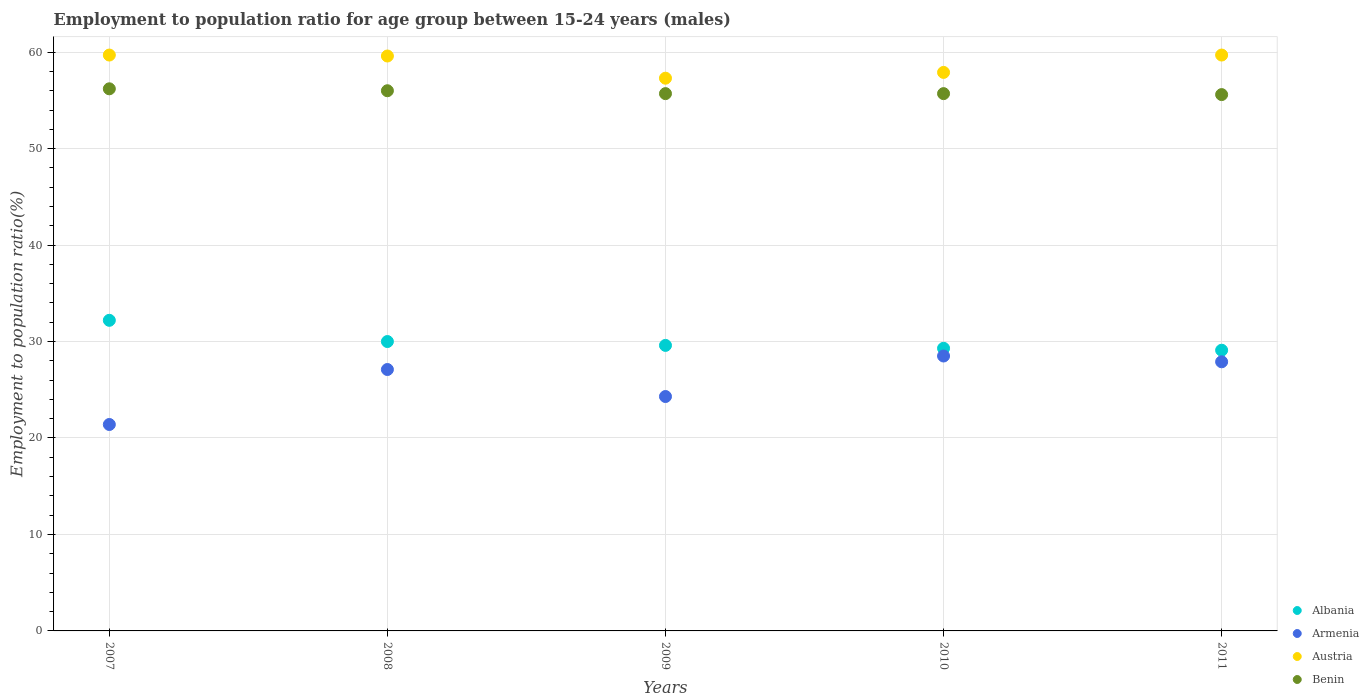How many different coloured dotlines are there?
Offer a very short reply. 4. Is the number of dotlines equal to the number of legend labels?
Keep it short and to the point. Yes. What is the employment to population ratio in Albania in 2009?
Give a very brief answer. 29.6. Across all years, what is the maximum employment to population ratio in Benin?
Your answer should be very brief. 56.2. Across all years, what is the minimum employment to population ratio in Benin?
Offer a very short reply. 55.6. What is the total employment to population ratio in Albania in the graph?
Provide a short and direct response. 150.2. What is the difference between the employment to population ratio in Austria in 2007 and that in 2008?
Offer a terse response. 0.1. What is the difference between the employment to population ratio in Austria in 2009 and the employment to population ratio in Armenia in 2008?
Keep it short and to the point. 30.2. What is the average employment to population ratio in Albania per year?
Keep it short and to the point. 30.04. In the year 2011, what is the difference between the employment to population ratio in Austria and employment to population ratio in Albania?
Your answer should be compact. 30.6. What is the ratio of the employment to population ratio in Benin in 2008 to that in 2009?
Your response must be concise. 1.01. Is the employment to population ratio in Albania in 2007 less than that in 2010?
Make the answer very short. No. What is the difference between the highest and the second highest employment to population ratio in Austria?
Keep it short and to the point. 0. What is the difference between the highest and the lowest employment to population ratio in Armenia?
Offer a very short reply. 7.1. In how many years, is the employment to population ratio in Austria greater than the average employment to population ratio in Austria taken over all years?
Offer a very short reply. 3. Is the sum of the employment to population ratio in Austria in 2007 and 2011 greater than the maximum employment to population ratio in Armenia across all years?
Offer a terse response. Yes. Is it the case that in every year, the sum of the employment to population ratio in Austria and employment to population ratio in Benin  is greater than the employment to population ratio in Albania?
Your answer should be very brief. Yes. Does the employment to population ratio in Austria monotonically increase over the years?
Your answer should be very brief. No. Is the employment to population ratio in Benin strictly greater than the employment to population ratio in Albania over the years?
Provide a short and direct response. Yes. Is the employment to population ratio in Benin strictly less than the employment to population ratio in Austria over the years?
Keep it short and to the point. Yes. What is the difference between two consecutive major ticks on the Y-axis?
Offer a terse response. 10. Does the graph contain grids?
Keep it short and to the point. Yes. How many legend labels are there?
Make the answer very short. 4. How are the legend labels stacked?
Make the answer very short. Vertical. What is the title of the graph?
Your answer should be very brief. Employment to population ratio for age group between 15-24 years (males). What is the label or title of the X-axis?
Your answer should be compact. Years. What is the label or title of the Y-axis?
Your answer should be compact. Employment to population ratio(%). What is the Employment to population ratio(%) in Albania in 2007?
Offer a terse response. 32.2. What is the Employment to population ratio(%) in Armenia in 2007?
Provide a short and direct response. 21.4. What is the Employment to population ratio(%) of Austria in 2007?
Offer a terse response. 59.7. What is the Employment to population ratio(%) of Benin in 2007?
Provide a succinct answer. 56.2. What is the Employment to population ratio(%) in Armenia in 2008?
Your answer should be compact. 27.1. What is the Employment to population ratio(%) of Austria in 2008?
Your answer should be compact. 59.6. What is the Employment to population ratio(%) of Benin in 2008?
Ensure brevity in your answer.  56. What is the Employment to population ratio(%) of Albania in 2009?
Give a very brief answer. 29.6. What is the Employment to population ratio(%) of Armenia in 2009?
Your answer should be compact. 24.3. What is the Employment to population ratio(%) of Austria in 2009?
Your answer should be compact. 57.3. What is the Employment to population ratio(%) in Benin in 2009?
Make the answer very short. 55.7. What is the Employment to population ratio(%) of Albania in 2010?
Your response must be concise. 29.3. What is the Employment to population ratio(%) in Armenia in 2010?
Keep it short and to the point. 28.5. What is the Employment to population ratio(%) in Austria in 2010?
Offer a very short reply. 57.9. What is the Employment to population ratio(%) in Benin in 2010?
Your answer should be compact. 55.7. What is the Employment to population ratio(%) in Albania in 2011?
Offer a terse response. 29.1. What is the Employment to population ratio(%) of Armenia in 2011?
Keep it short and to the point. 27.9. What is the Employment to population ratio(%) of Austria in 2011?
Offer a very short reply. 59.7. What is the Employment to population ratio(%) of Benin in 2011?
Your response must be concise. 55.6. Across all years, what is the maximum Employment to population ratio(%) of Albania?
Provide a short and direct response. 32.2. Across all years, what is the maximum Employment to population ratio(%) in Austria?
Give a very brief answer. 59.7. Across all years, what is the maximum Employment to population ratio(%) of Benin?
Your response must be concise. 56.2. Across all years, what is the minimum Employment to population ratio(%) in Albania?
Your response must be concise. 29.1. Across all years, what is the minimum Employment to population ratio(%) in Armenia?
Keep it short and to the point. 21.4. Across all years, what is the minimum Employment to population ratio(%) in Austria?
Keep it short and to the point. 57.3. Across all years, what is the minimum Employment to population ratio(%) in Benin?
Your answer should be compact. 55.6. What is the total Employment to population ratio(%) of Albania in the graph?
Ensure brevity in your answer.  150.2. What is the total Employment to population ratio(%) in Armenia in the graph?
Your answer should be very brief. 129.2. What is the total Employment to population ratio(%) in Austria in the graph?
Offer a terse response. 294.2. What is the total Employment to population ratio(%) in Benin in the graph?
Give a very brief answer. 279.2. What is the difference between the Employment to population ratio(%) in Armenia in 2007 and that in 2008?
Ensure brevity in your answer.  -5.7. What is the difference between the Employment to population ratio(%) of Austria in 2007 and that in 2008?
Your answer should be very brief. 0.1. What is the difference between the Employment to population ratio(%) in Benin in 2007 and that in 2008?
Provide a succinct answer. 0.2. What is the difference between the Employment to population ratio(%) in Albania in 2007 and that in 2009?
Offer a very short reply. 2.6. What is the difference between the Employment to population ratio(%) of Armenia in 2007 and that in 2009?
Offer a terse response. -2.9. What is the difference between the Employment to population ratio(%) in Austria in 2007 and that in 2009?
Provide a short and direct response. 2.4. What is the difference between the Employment to population ratio(%) of Albania in 2007 and that in 2010?
Give a very brief answer. 2.9. What is the difference between the Employment to population ratio(%) in Austria in 2007 and that in 2010?
Ensure brevity in your answer.  1.8. What is the difference between the Employment to population ratio(%) of Albania in 2007 and that in 2011?
Offer a terse response. 3.1. What is the difference between the Employment to population ratio(%) of Benin in 2007 and that in 2011?
Give a very brief answer. 0.6. What is the difference between the Employment to population ratio(%) of Albania in 2008 and that in 2009?
Provide a short and direct response. 0.4. What is the difference between the Employment to population ratio(%) of Armenia in 2008 and that in 2009?
Your answer should be compact. 2.8. What is the difference between the Employment to population ratio(%) of Albania in 2008 and that in 2010?
Your response must be concise. 0.7. What is the difference between the Employment to population ratio(%) of Armenia in 2008 and that in 2010?
Keep it short and to the point. -1.4. What is the difference between the Employment to population ratio(%) of Austria in 2008 and that in 2010?
Keep it short and to the point. 1.7. What is the difference between the Employment to population ratio(%) in Benin in 2008 and that in 2011?
Ensure brevity in your answer.  0.4. What is the difference between the Employment to population ratio(%) of Albania in 2009 and that in 2010?
Provide a short and direct response. 0.3. What is the difference between the Employment to population ratio(%) in Armenia in 2009 and that in 2010?
Give a very brief answer. -4.2. What is the difference between the Employment to population ratio(%) of Albania in 2009 and that in 2011?
Offer a very short reply. 0.5. What is the difference between the Employment to population ratio(%) of Benin in 2009 and that in 2011?
Your answer should be very brief. 0.1. What is the difference between the Employment to population ratio(%) in Albania in 2010 and that in 2011?
Your response must be concise. 0.2. What is the difference between the Employment to population ratio(%) in Austria in 2010 and that in 2011?
Give a very brief answer. -1.8. What is the difference between the Employment to population ratio(%) of Albania in 2007 and the Employment to population ratio(%) of Austria in 2008?
Your answer should be very brief. -27.4. What is the difference between the Employment to population ratio(%) in Albania in 2007 and the Employment to population ratio(%) in Benin in 2008?
Offer a terse response. -23.8. What is the difference between the Employment to population ratio(%) of Armenia in 2007 and the Employment to population ratio(%) of Austria in 2008?
Offer a terse response. -38.2. What is the difference between the Employment to population ratio(%) of Armenia in 2007 and the Employment to population ratio(%) of Benin in 2008?
Offer a very short reply. -34.6. What is the difference between the Employment to population ratio(%) in Austria in 2007 and the Employment to population ratio(%) in Benin in 2008?
Your answer should be very brief. 3.7. What is the difference between the Employment to population ratio(%) of Albania in 2007 and the Employment to population ratio(%) of Armenia in 2009?
Keep it short and to the point. 7.9. What is the difference between the Employment to population ratio(%) in Albania in 2007 and the Employment to population ratio(%) in Austria in 2009?
Offer a very short reply. -25.1. What is the difference between the Employment to population ratio(%) of Albania in 2007 and the Employment to population ratio(%) of Benin in 2009?
Offer a terse response. -23.5. What is the difference between the Employment to population ratio(%) in Armenia in 2007 and the Employment to population ratio(%) in Austria in 2009?
Your answer should be compact. -35.9. What is the difference between the Employment to population ratio(%) in Armenia in 2007 and the Employment to population ratio(%) in Benin in 2009?
Your answer should be very brief. -34.3. What is the difference between the Employment to population ratio(%) in Albania in 2007 and the Employment to population ratio(%) in Austria in 2010?
Offer a very short reply. -25.7. What is the difference between the Employment to population ratio(%) in Albania in 2007 and the Employment to population ratio(%) in Benin in 2010?
Provide a succinct answer. -23.5. What is the difference between the Employment to population ratio(%) in Armenia in 2007 and the Employment to population ratio(%) in Austria in 2010?
Give a very brief answer. -36.5. What is the difference between the Employment to population ratio(%) of Armenia in 2007 and the Employment to population ratio(%) of Benin in 2010?
Provide a short and direct response. -34.3. What is the difference between the Employment to population ratio(%) of Albania in 2007 and the Employment to population ratio(%) of Austria in 2011?
Your response must be concise. -27.5. What is the difference between the Employment to population ratio(%) of Albania in 2007 and the Employment to population ratio(%) of Benin in 2011?
Your answer should be compact. -23.4. What is the difference between the Employment to population ratio(%) of Armenia in 2007 and the Employment to population ratio(%) of Austria in 2011?
Your answer should be very brief. -38.3. What is the difference between the Employment to population ratio(%) of Armenia in 2007 and the Employment to population ratio(%) of Benin in 2011?
Your answer should be compact. -34.2. What is the difference between the Employment to population ratio(%) in Albania in 2008 and the Employment to population ratio(%) in Austria in 2009?
Provide a succinct answer. -27.3. What is the difference between the Employment to population ratio(%) in Albania in 2008 and the Employment to population ratio(%) in Benin in 2009?
Offer a terse response. -25.7. What is the difference between the Employment to population ratio(%) of Armenia in 2008 and the Employment to population ratio(%) of Austria in 2009?
Provide a short and direct response. -30.2. What is the difference between the Employment to population ratio(%) of Armenia in 2008 and the Employment to population ratio(%) of Benin in 2009?
Your response must be concise. -28.6. What is the difference between the Employment to population ratio(%) in Austria in 2008 and the Employment to population ratio(%) in Benin in 2009?
Offer a terse response. 3.9. What is the difference between the Employment to population ratio(%) in Albania in 2008 and the Employment to population ratio(%) in Armenia in 2010?
Offer a terse response. 1.5. What is the difference between the Employment to population ratio(%) of Albania in 2008 and the Employment to population ratio(%) of Austria in 2010?
Offer a terse response. -27.9. What is the difference between the Employment to population ratio(%) in Albania in 2008 and the Employment to population ratio(%) in Benin in 2010?
Give a very brief answer. -25.7. What is the difference between the Employment to population ratio(%) of Armenia in 2008 and the Employment to population ratio(%) of Austria in 2010?
Ensure brevity in your answer.  -30.8. What is the difference between the Employment to population ratio(%) of Armenia in 2008 and the Employment to population ratio(%) of Benin in 2010?
Your response must be concise. -28.6. What is the difference between the Employment to population ratio(%) in Albania in 2008 and the Employment to population ratio(%) in Austria in 2011?
Provide a succinct answer. -29.7. What is the difference between the Employment to population ratio(%) in Albania in 2008 and the Employment to population ratio(%) in Benin in 2011?
Your answer should be very brief. -25.6. What is the difference between the Employment to population ratio(%) of Armenia in 2008 and the Employment to population ratio(%) of Austria in 2011?
Offer a terse response. -32.6. What is the difference between the Employment to population ratio(%) of Armenia in 2008 and the Employment to population ratio(%) of Benin in 2011?
Provide a succinct answer. -28.5. What is the difference between the Employment to population ratio(%) of Albania in 2009 and the Employment to population ratio(%) of Armenia in 2010?
Provide a succinct answer. 1.1. What is the difference between the Employment to population ratio(%) of Albania in 2009 and the Employment to population ratio(%) of Austria in 2010?
Your answer should be compact. -28.3. What is the difference between the Employment to population ratio(%) of Albania in 2009 and the Employment to population ratio(%) of Benin in 2010?
Your answer should be compact. -26.1. What is the difference between the Employment to population ratio(%) of Armenia in 2009 and the Employment to population ratio(%) of Austria in 2010?
Provide a short and direct response. -33.6. What is the difference between the Employment to population ratio(%) of Armenia in 2009 and the Employment to population ratio(%) of Benin in 2010?
Your answer should be very brief. -31.4. What is the difference between the Employment to population ratio(%) of Austria in 2009 and the Employment to population ratio(%) of Benin in 2010?
Your answer should be compact. 1.6. What is the difference between the Employment to population ratio(%) of Albania in 2009 and the Employment to population ratio(%) of Austria in 2011?
Your answer should be very brief. -30.1. What is the difference between the Employment to population ratio(%) of Albania in 2009 and the Employment to population ratio(%) of Benin in 2011?
Ensure brevity in your answer.  -26. What is the difference between the Employment to population ratio(%) in Armenia in 2009 and the Employment to population ratio(%) in Austria in 2011?
Your answer should be compact. -35.4. What is the difference between the Employment to population ratio(%) of Armenia in 2009 and the Employment to population ratio(%) of Benin in 2011?
Ensure brevity in your answer.  -31.3. What is the difference between the Employment to population ratio(%) of Austria in 2009 and the Employment to population ratio(%) of Benin in 2011?
Provide a short and direct response. 1.7. What is the difference between the Employment to population ratio(%) of Albania in 2010 and the Employment to population ratio(%) of Armenia in 2011?
Ensure brevity in your answer.  1.4. What is the difference between the Employment to population ratio(%) of Albania in 2010 and the Employment to population ratio(%) of Austria in 2011?
Provide a succinct answer. -30.4. What is the difference between the Employment to population ratio(%) in Albania in 2010 and the Employment to population ratio(%) in Benin in 2011?
Ensure brevity in your answer.  -26.3. What is the difference between the Employment to population ratio(%) of Armenia in 2010 and the Employment to population ratio(%) of Austria in 2011?
Your answer should be compact. -31.2. What is the difference between the Employment to population ratio(%) in Armenia in 2010 and the Employment to population ratio(%) in Benin in 2011?
Keep it short and to the point. -27.1. What is the average Employment to population ratio(%) in Albania per year?
Offer a very short reply. 30.04. What is the average Employment to population ratio(%) of Armenia per year?
Offer a very short reply. 25.84. What is the average Employment to population ratio(%) of Austria per year?
Your response must be concise. 58.84. What is the average Employment to population ratio(%) in Benin per year?
Your answer should be very brief. 55.84. In the year 2007, what is the difference between the Employment to population ratio(%) of Albania and Employment to population ratio(%) of Armenia?
Provide a short and direct response. 10.8. In the year 2007, what is the difference between the Employment to population ratio(%) of Albania and Employment to population ratio(%) of Austria?
Ensure brevity in your answer.  -27.5. In the year 2007, what is the difference between the Employment to population ratio(%) of Albania and Employment to population ratio(%) of Benin?
Make the answer very short. -24. In the year 2007, what is the difference between the Employment to population ratio(%) in Armenia and Employment to population ratio(%) in Austria?
Your answer should be very brief. -38.3. In the year 2007, what is the difference between the Employment to population ratio(%) in Armenia and Employment to population ratio(%) in Benin?
Make the answer very short. -34.8. In the year 2007, what is the difference between the Employment to population ratio(%) in Austria and Employment to population ratio(%) in Benin?
Provide a succinct answer. 3.5. In the year 2008, what is the difference between the Employment to population ratio(%) of Albania and Employment to population ratio(%) of Austria?
Offer a terse response. -29.6. In the year 2008, what is the difference between the Employment to population ratio(%) of Albania and Employment to population ratio(%) of Benin?
Your answer should be very brief. -26. In the year 2008, what is the difference between the Employment to population ratio(%) in Armenia and Employment to population ratio(%) in Austria?
Give a very brief answer. -32.5. In the year 2008, what is the difference between the Employment to population ratio(%) of Armenia and Employment to population ratio(%) of Benin?
Provide a short and direct response. -28.9. In the year 2009, what is the difference between the Employment to population ratio(%) in Albania and Employment to population ratio(%) in Austria?
Make the answer very short. -27.7. In the year 2009, what is the difference between the Employment to population ratio(%) of Albania and Employment to population ratio(%) of Benin?
Your response must be concise. -26.1. In the year 2009, what is the difference between the Employment to population ratio(%) of Armenia and Employment to population ratio(%) of Austria?
Ensure brevity in your answer.  -33. In the year 2009, what is the difference between the Employment to population ratio(%) in Armenia and Employment to population ratio(%) in Benin?
Make the answer very short. -31.4. In the year 2009, what is the difference between the Employment to population ratio(%) in Austria and Employment to population ratio(%) in Benin?
Your answer should be very brief. 1.6. In the year 2010, what is the difference between the Employment to population ratio(%) of Albania and Employment to population ratio(%) of Armenia?
Offer a terse response. 0.8. In the year 2010, what is the difference between the Employment to population ratio(%) in Albania and Employment to population ratio(%) in Austria?
Your answer should be very brief. -28.6. In the year 2010, what is the difference between the Employment to population ratio(%) in Albania and Employment to population ratio(%) in Benin?
Your response must be concise. -26.4. In the year 2010, what is the difference between the Employment to population ratio(%) in Armenia and Employment to population ratio(%) in Austria?
Provide a succinct answer. -29.4. In the year 2010, what is the difference between the Employment to population ratio(%) of Armenia and Employment to population ratio(%) of Benin?
Give a very brief answer. -27.2. In the year 2011, what is the difference between the Employment to population ratio(%) in Albania and Employment to population ratio(%) in Austria?
Offer a very short reply. -30.6. In the year 2011, what is the difference between the Employment to population ratio(%) of Albania and Employment to population ratio(%) of Benin?
Provide a succinct answer. -26.5. In the year 2011, what is the difference between the Employment to population ratio(%) in Armenia and Employment to population ratio(%) in Austria?
Provide a succinct answer. -31.8. In the year 2011, what is the difference between the Employment to population ratio(%) in Armenia and Employment to population ratio(%) in Benin?
Your answer should be very brief. -27.7. In the year 2011, what is the difference between the Employment to population ratio(%) in Austria and Employment to population ratio(%) in Benin?
Ensure brevity in your answer.  4.1. What is the ratio of the Employment to population ratio(%) of Albania in 2007 to that in 2008?
Provide a succinct answer. 1.07. What is the ratio of the Employment to population ratio(%) in Armenia in 2007 to that in 2008?
Your answer should be compact. 0.79. What is the ratio of the Employment to population ratio(%) in Benin in 2007 to that in 2008?
Make the answer very short. 1. What is the ratio of the Employment to population ratio(%) of Albania in 2007 to that in 2009?
Keep it short and to the point. 1.09. What is the ratio of the Employment to population ratio(%) of Armenia in 2007 to that in 2009?
Your response must be concise. 0.88. What is the ratio of the Employment to population ratio(%) in Austria in 2007 to that in 2009?
Ensure brevity in your answer.  1.04. What is the ratio of the Employment to population ratio(%) of Albania in 2007 to that in 2010?
Ensure brevity in your answer.  1.1. What is the ratio of the Employment to population ratio(%) of Armenia in 2007 to that in 2010?
Make the answer very short. 0.75. What is the ratio of the Employment to population ratio(%) of Austria in 2007 to that in 2010?
Provide a succinct answer. 1.03. What is the ratio of the Employment to population ratio(%) of Benin in 2007 to that in 2010?
Your answer should be compact. 1.01. What is the ratio of the Employment to population ratio(%) in Albania in 2007 to that in 2011?
Offer a very short reply. 1.11. What is the ratio of the Employment to population ratio(%) of Armenia in 2007 to that in 2011?
Provide a succinct answer. 0.77. What is the ratio of the Employment to population ratio(%) in Benin in 2007 to that in 2011?
Make the answer very short. 1.01. What is the ratio of the Employment to population ratio(%) of Albania in 2008 to that in 2009?
Give a very brief answer. 1.01. What is the ratio of the Employment to population ratio(%) of Armenia in 2008 to that in 2009?
Keep it short and to the point. 1.12. What is the ratio of the Employment to population ratio(%) of Austria in 2008 to that in 2009?
Offer a very short reply. 1.04. What is the ratio of the Employment to population ratio(%) of Benin in 2008 to that in 2009?
Give a very brief answer. 1.01. What is the ratio of the Employment to population ratio(%) in Albania in 2008 to that in 2010?
Offer a very short reply. 1.02. What is the ratio of the Employment to population ratio(%) in Armenia in 2008 to that in 2010?
Your answer should be compact. 0.95. What is the ratio of the Employment to population ratio(%) in Austria in 2008 to that in 2010?
Offer a very short reply. 1.03. What is the ratio of the Employment to population ratio(%) of Benin in 2008 to that in 2010?
Your response must be concise. 1.01. What is the ratio of the Employment to population ratio(%) of Albania in 2008 to that in 2011?
Keep it short and to the point. 1.03. What is the ratio of the Employment to population ratio(%) in Armenia in 2008 to that in 2011?
Provide a short and direct response. 0.97. What is the ratio of the Employment to population ratio(%) in Austria in 2008 to that in 2011?
Give a very brief answer. 1. What is the ratio of the Employment to population ratio(%) of Albania in 2009 to that in 2010?
Your response must be concise. 1.01. What is the ratio of the Employment to population ratio(%) of Armenia in 2009 to that in 2010?
Keep it short and to the point. 0.85. What is the ratio of the Employment to population ratio(%) in Austria in 2009 to that in 2010?
Your response must be concise. 0.99. What is the ratio of the Employment to population ratio(%) of Albania in 2009 to that in 2011?
Your response must be concise. 1.02. What is the ratio of the Employment to population ratio(%) in Armenia in 2009 to that in 2011?
Ensure brevity in your answer.  0.87. What is the ratio of the Employment to population ratio(%) in Austria in 2009 to that in 2011?
Provide a succinct answer. 0.96. What is the ratio of the Employment to population ratio(%) of Benin in 2009 to that in 2011?
Keep it short and to the point. 1. What is the ratio of the Employment to population ratio(%) in Albania in 2010 to that in 2011?
Give a very brief answer. 1.01. What is the ratio of the Employment to population ratio(%) in Armenia in 2010 to that in 2011?
Keep it short and to the point. 1.02. What is the ratio of the Employment to population ratio(%) in Austria in 2010 to that in 2011?
Keep it short and to the point. 0.97. What is the ratio of the Employment to population ratio(%) of Benin in 2010 to that in 2011?
Your response must be concise. 1. What is the difference between the highest and the second highest Employment to population ratio(%) of Albania?
Make the answer very short. 2.2. What is the difference between the highest and the lowest Employment to population ratio(%) of Benin?
Your answer should be very brief. 0.6. 